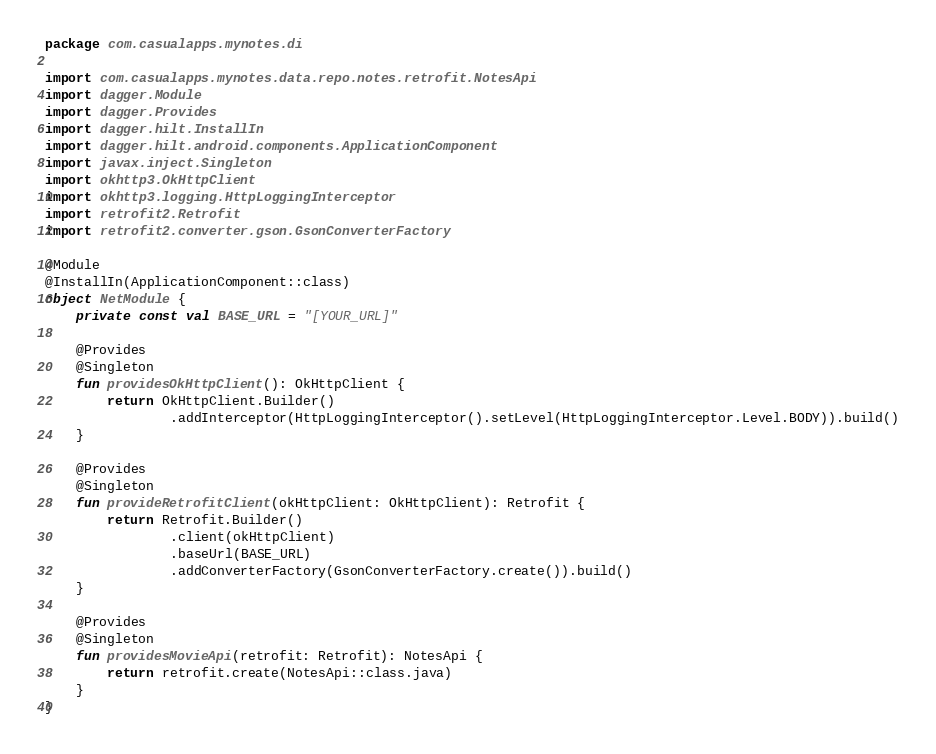Convert code to text. <code><loc_0><loc_0><loc_500><loc_500><_Kotlin_>package com.casualapps.mynotes.di

import com.casualapps.mynotes.data.repo.notes.retrofit.NotesApi
import dagger.Module
import dagger.Provides
import dagger.hilt.InstallIn
import dagger.hilt.android.components.ApplicationComponent
import javax.inject.Singleton
import okhttp3.OkHttpClient
import okhttp3.logging.HttpLoggingInterceptor
import retrofit2.Retrofit
import retrofit2.converter.gson.GsonConverterFactory

@Module
@InstallIn(ApplicationComponent::class)
object NetModule {
    private const val BASE_URL = "[YOUR_URL]"

    @Provides
    @Singleton
    fun providesOkHttpClient(): OkHttpClient {
        return OkHttpClient.Builder()
                .addInterceptor(HttpLoggingInterceptor().setLevel(HttpLoggingInterceptor.Level.BODY)).build()
    }

    @Provides
    @Singleton
    fun provideRetrofitClient(okHttpClient: OkHttpClient): Retrofit {
        return Retrofit.Builder()
                .client(okHttpClient)
                .baseUrl(BASE_URL)
                .addConverterFactory(GsonConverterFactory.create()).build()
    }

    @Provides
    @Singleton
    fun providesMovieApi(retrofit: Retrofit): NotesApi {
        return retrofit.create(NotesApi::class.java)
    }
}
</code> 